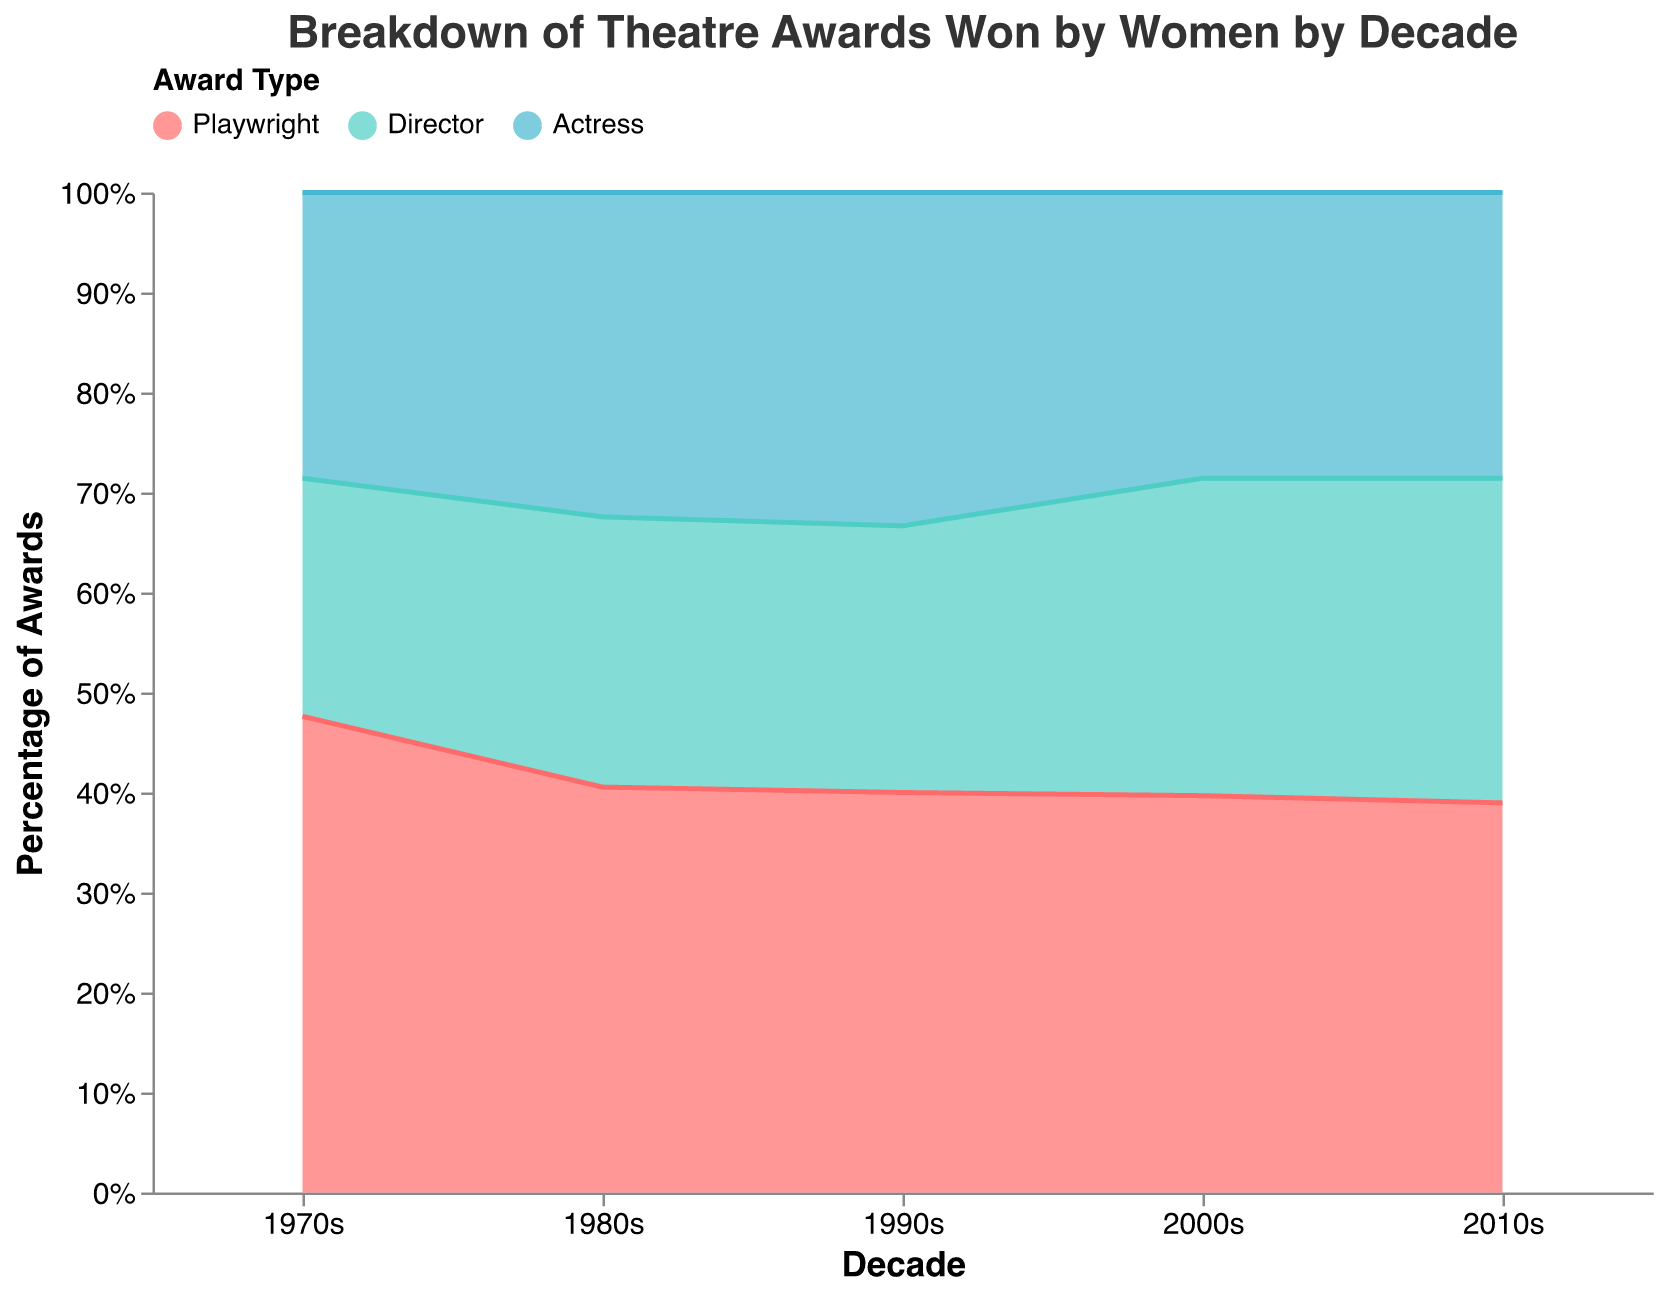What is the title of the chart? The title of the chart is displayed at the top in a larger font size and says "Breakdown of Theatre Awards Won by Women by Decade".
Answer: Breakdown of Theatre Awards Won by Women by Decade Which color represents the "Director" category? The color representation for the "Director" category is shown in the legend. The color next to "Director" is a turquoise-like color.
Answer: Turquoise In which decade did "Playwrights" win the most Drama Desk Awards? To determine this, look for the pink area (representing Playwrights) and find the decade where this area reaches its highest point with respect to the Drama Desk Awards. In the 2010s, Playwrights won the most Drama Desk Awards with 40.
Answer: 2010s Which decade saw the largest number of Tony Awards won by "Actresses"? Examine the blue area corresponding to "Actresses" and determine the decade where this section extends furthest for the Tony Awards. This occurs in the 2010s.
Answer: 2010s How many Tony Awards did women win as Directors in the 2000s? Locate the turquoise area for "Director" during the 2000s, and refer to the tooltip for Tony Awards which is 15.
Answer: 15 What is the trend in the number of Sir Laurence Olivier Awards won by Playwrights from the 1970s to the 2010s? Look at the pink area representing Playwrights across all the decades for the Sir Laurence Olivier Awards. The chart shows a consistent increase in awards won by Playwrights from the 1970s to the 2010s (10 in the 1970s to 30 in the 2010s).
Answer: Increasing Compare the number of Drama Desk Awards won by Actresses in the 1980s to the number won by Directors in the same decade. Examine the blue area for "Actresses" and the turquoise area for "Directors" in the 1980s. Actresses won 22 Drama Desk Awards while Directors won 12.
Answer: Actresses won 10 more Drama Desk Awards What percentage of the total awards in the 1980s was won by Playwrights? To get the percentage, normalize the awards across all categories for the 1980s decade, then check how much of this total corresponds to Playwrights. According to the stacked area chart, Playwrights contributed the largest share of awards in the 1980s.
Answer: Highest percentage in the 1980s Which award type has no Pulitzer Prize for Drama wins in any decade? Check each decade area across all award types for the Pulitzer Prize for Drama section. There are no Pulitzer Prize for Drama awards for Actresses in any decade.
Answer: Actresses What do you observe about the trend in the number of Obie Awards won by Directors from the 1970s to the 2010s? Focusing on the turquoise areas (Directors) for the Obie Awards across all decades, you can observe an upward trend: starting from 2 in the 1970s and increasing to 15 in the 2010s.
Answer: Upward trend 